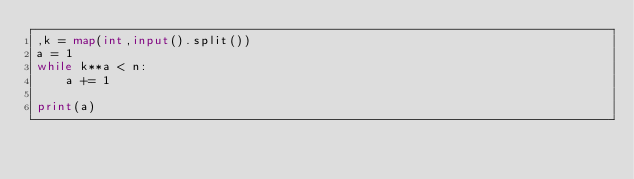<code> <loc_0><loc_0><loc_500><loc_500><_Python_>,k = map(int,input().split())
a = 1
while k**a < n:
    a += 1

print(a)</code> 